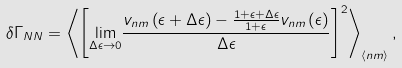<formula> <loc_0><loc_0><loc_500><loc_500>\delta \Gamma _ { N N } = \left \langle \left [ \underset { \Delta \epsilon \rightarrow 0 } { \lim } \frac { v _ { n m } \left ( \epsilon + \Delta \epsilon \right ) - \frac { 1 + \epsilon + \Delta \epsilon } { 1 + \epsilon } v _ { n m } \left ( \epsilon \right ) } { \Delta \epsilon } \right ] ^ { 2 } \right \rangle _ { \left < n m \right > } ,</formula> 